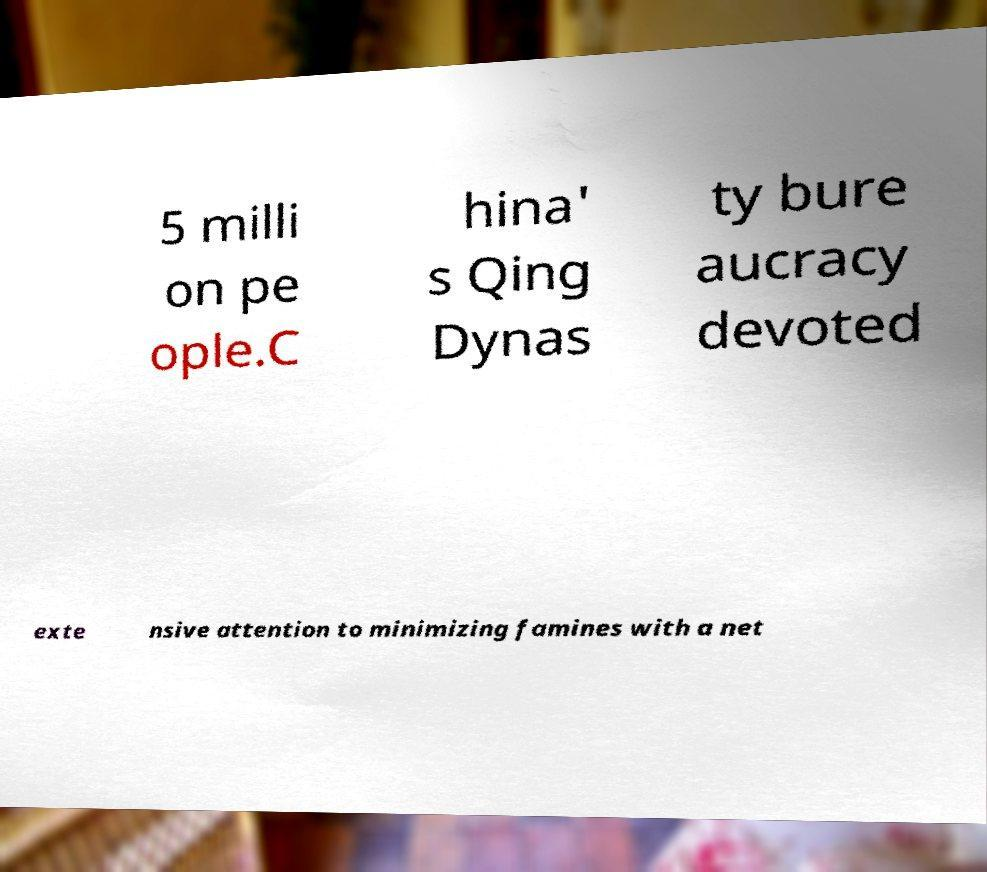Can you read and provide the text displayed in the image?This photo seems to have some interesting text. Can you extract and type it out for me? 5 milli on pe ople.C hina' s Qing Dynas ty bure aucracy devoted exte nsive attention to minimizing famines with a net 